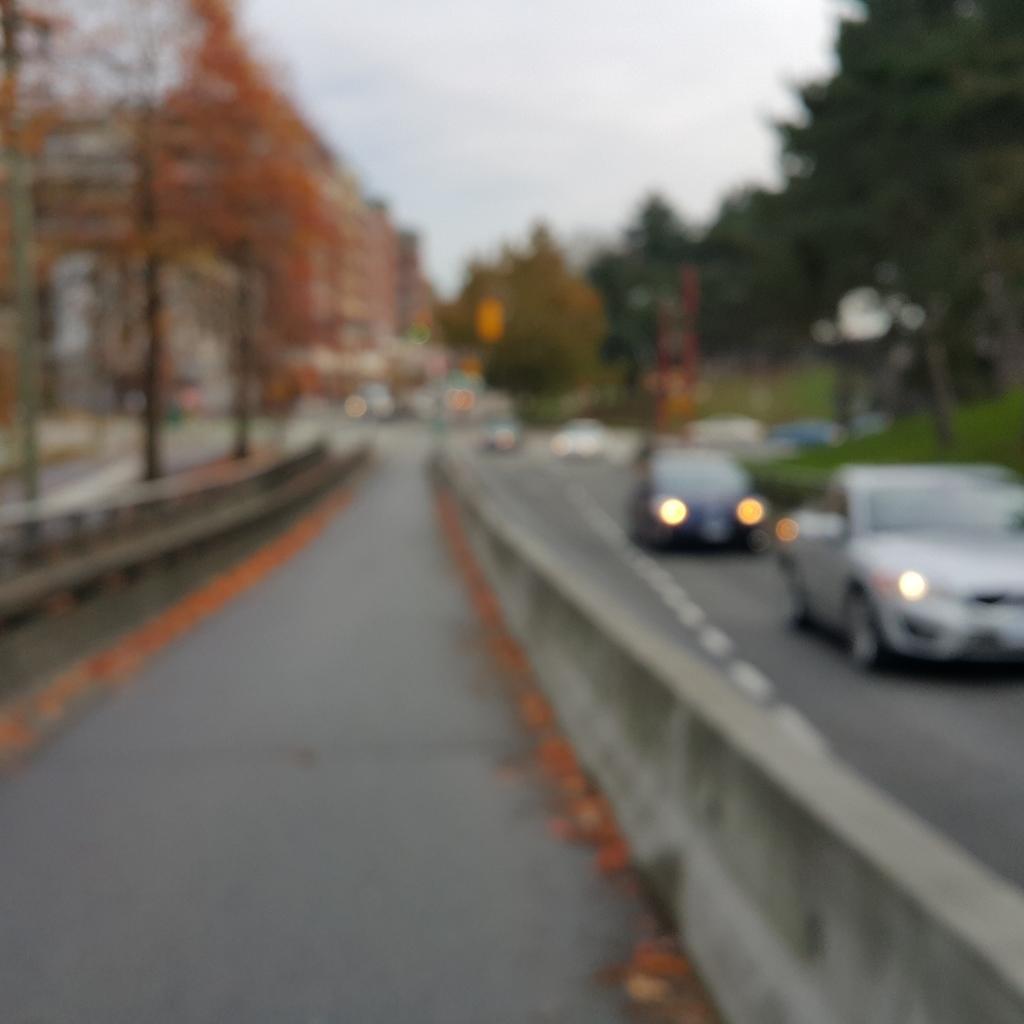Can you describe this image briefly? This is a blurred image, we can see there are vehicles on the road and in between the road there is a road divider. Behind the vehicles there are buildings, trees and a sky. 